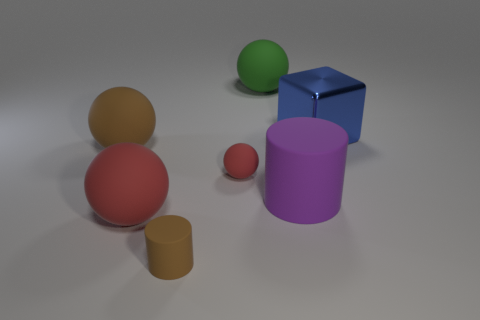Is there anything else that is made of the same material as the cube?
Provide a short and direct response. No. Is the tiny brown object made of the same material as the big brown ball?
Ensure brevity in your answer.  Yes. What number of large objects are the same color as the small cylinder?
Make the answer very short. 1. There is a blue cube behind the small brown cylinder; what is it made of?
Provide a short and direct response. Metal. What number of big things are either red matte spheres or cylinders?
Offer a very short reply. 2. Is there a large red object made of the same material as the purple cylinder?
Offer a terse response. Yes. There is a brown rubber object in front of the purple thing; does it have the same size as the tiny matte sphere?
Your response must be concise. Yes. There is a small matte thing behind the cylinder that is behind the brown cylinder; is there a purple thing that is behind it?
Ensure brevity in your answer.  No. How many rubber objects are tiny purple cylinders or tiny brown things?
Offer a terse response. 1. How many other objects are the same shape as the large brown matte thing?
Keep it short and to the point. 3. 